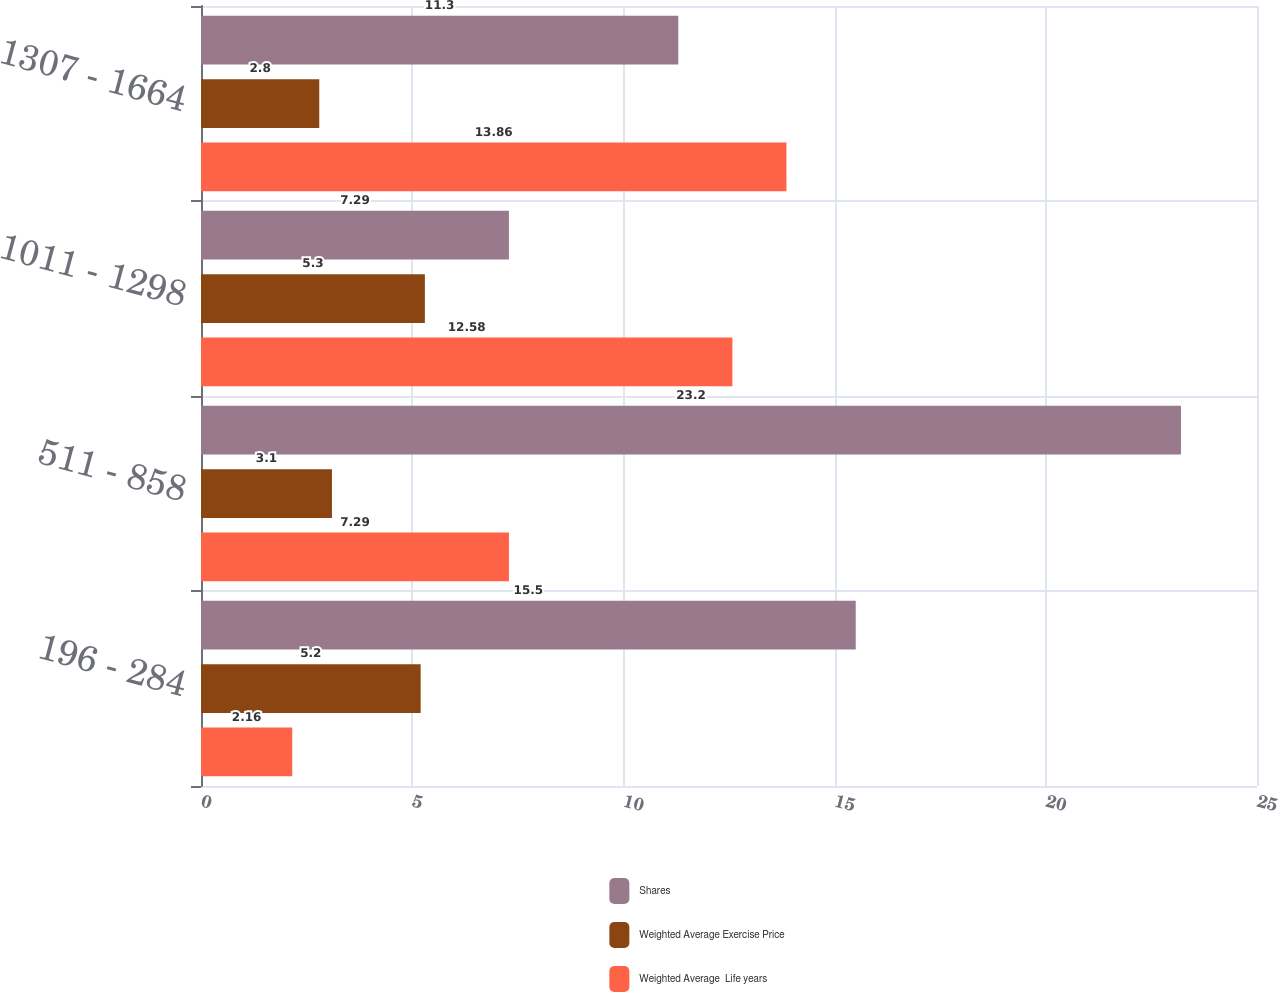Convert chart to OTSL. <chart><loc_0><loc_0><loc_500><loc_500><stacked_bar_chart><ecel><fcel>196 - 284<fcel>511 - 858<fcel>1011 - 1298<fcel>1307 - 1664<nl><fcel>Shares<fcel>15.5<fcel>23.2<fcel>7.29<fcel>11.3<nl><fcel>Weighted Average Exercise Price<fcel>5.2<fcel>3.1<fcel>5.3<fcel>2.8<nl><fcel>Weighted Average  Life years<fcel>2.16<fcel>7.29<fcel>12.58<fcel>13.86<nl></chart> 